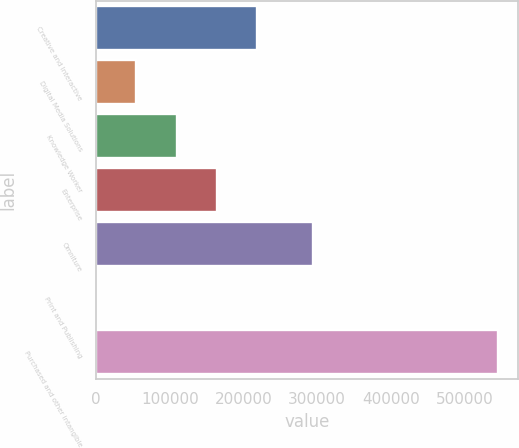<chart> <loc_0><loc_0><loc_500><loc_500><bar_chart><fcel>Creative and Interactive<fcel>Digital Media Solutions<fcel>Knowledge Worker<fcel>Enterprise<fcel>Omniture<fcel>Print and Publishing<fcel>Purchased and other intangible<nl><fcel>218301<fcel>54688.5<fcel>109226<fcel>163764<fcel>294656<fcel>151<fcel>545526<nl></chart> 